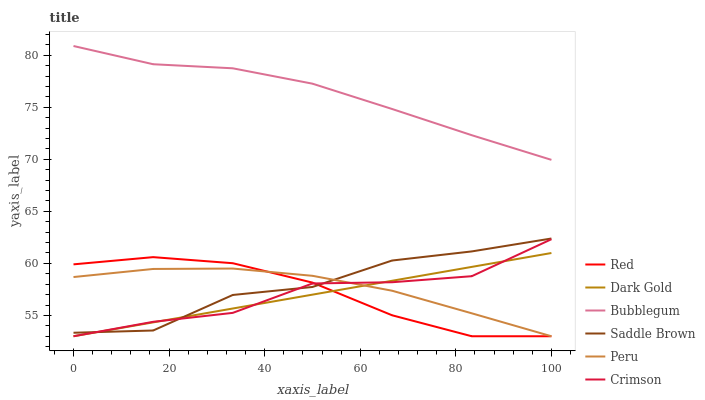Does Peru have the minimum area under the curve?
Answer yes or no. No. Does Peru have the maximum area under the curve?
Answer yes or no. No. Is Bubblegum the smoothest?
Answer yes or no. No. Is Bubblegum the roughest?
Answer yes or no. No. Does Bubblegum have the lowest value?
Answer yes or no. No. Does Peru have the highest value?
Answer yes or no. No. Is Saddle Brown less than Bubblegum?
Answer yes or no. Yes. Is Bubblegum greater than Red?
Answer yes or no. Yes. Does Saddle Brown intersect Bubblegum?
Answer yes or no. No. 